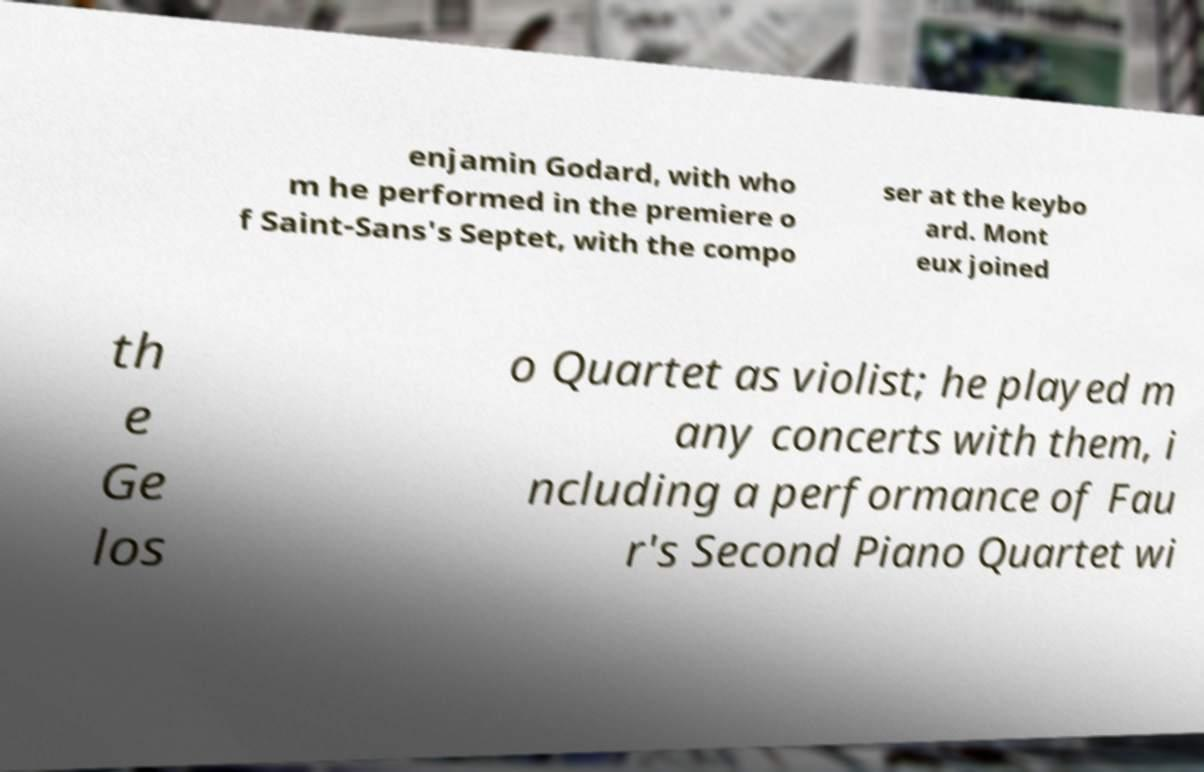Can you accurately transcribe the text from the provided image for me? enjamin Godard, with who m he performed in the premiere o f Saint-Sans's Septet, with the compo ser at the keybo ard. Mont eux joined th e Ge los o Quartet as violist; he played m any concerts with them, i ncluding a performance of Fau r's Second Piano Quartet wi 